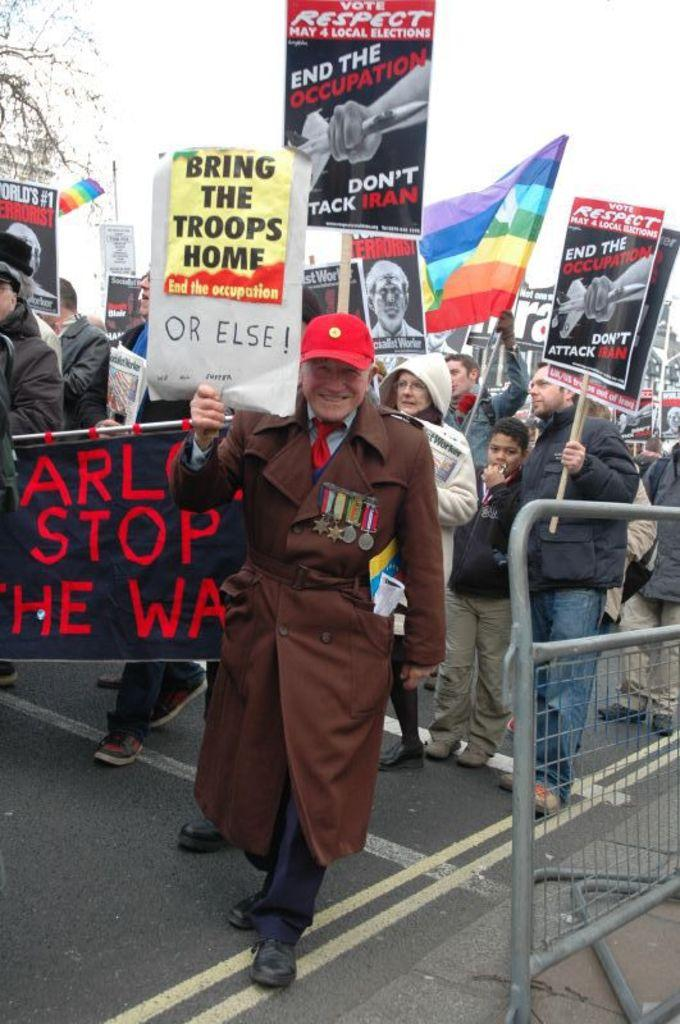What are the people in the image doing? The people in the image are standing on the road and holding placards and advertisements. What can be seen in the background of the image? There is sky, trees, and barriers visible in the background. Can you see the moon in the image? No, the moon is not visible in the image. What type of brush is being used by the people in the image? There is no brush present in the image; the people are holding placards and advertisements. 